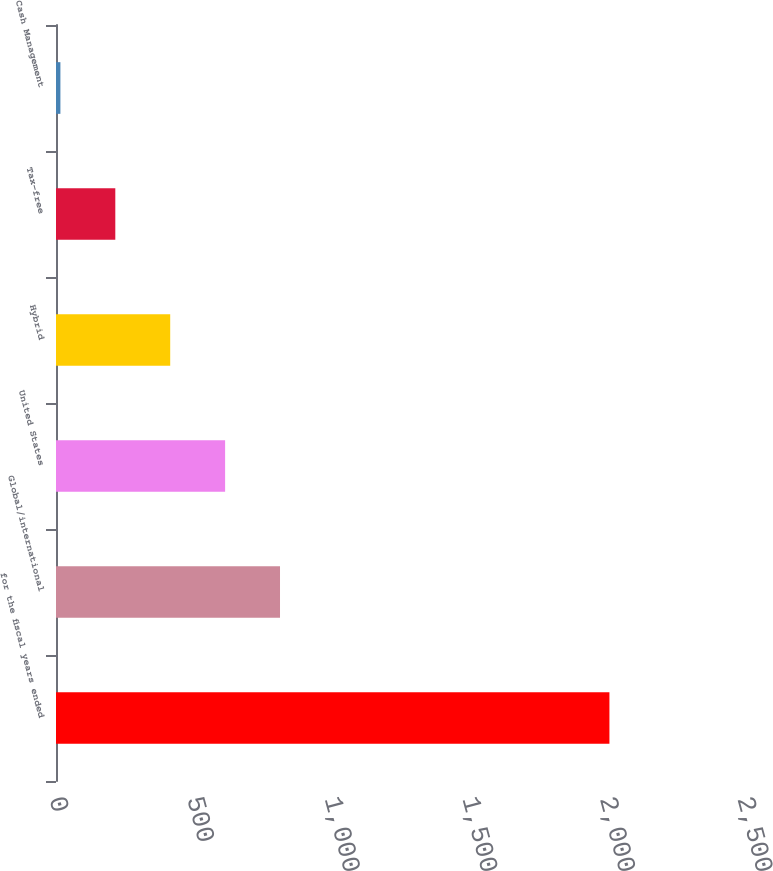Convert chart to OTSL. <chart><loc_0><loc_0><loc_500><loc_500><bar_chart><fcel>for the fiscal years ended<fcel>Global/international<fcel>United States<fcel>Hybrid<fcel>Tax-free<fcel>Cash Management<nl><fcel>2011<fcel>814<fcel>614.5<fcel>415<fcel>215.5<fcel>16<nl></chart> 